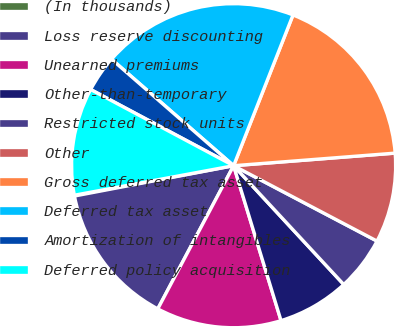<chart> <loc_0><loc_0><loc_500><loc_500><pie_chart><fcel>(In thousands)<fcel>Loss reserve discounting<fcel>Unearned premiums<fcel>Other-than-temporary<fcel>Restricted stock units<fcel>Other<fcel>Gross deferred tax asset<fcel>Deferred tax asset<fcel>Amortization of intangibles<fcel>Deferred policy acquisition<nl><fcel>0.08%<fcel>14.25%<fcel>12.48%<fcel>7.17%<fcel>5.4%<fcel>8.94%<fcel>17.79%<fcel>19.56%<fcel>3.62%<fcel>10.71%<nl></chart> 